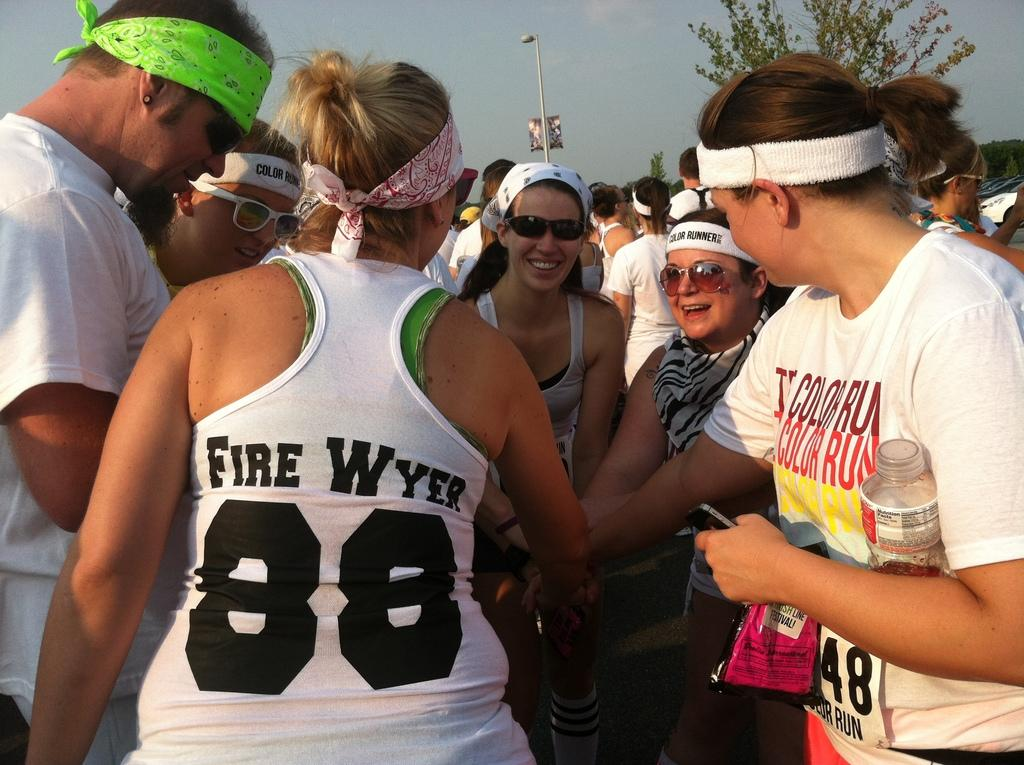<image>
Write a terse but informative summary of the picture. A girl wearing a white tank top with Fire Wyer printed on the back is huddled in a circle with several others. 